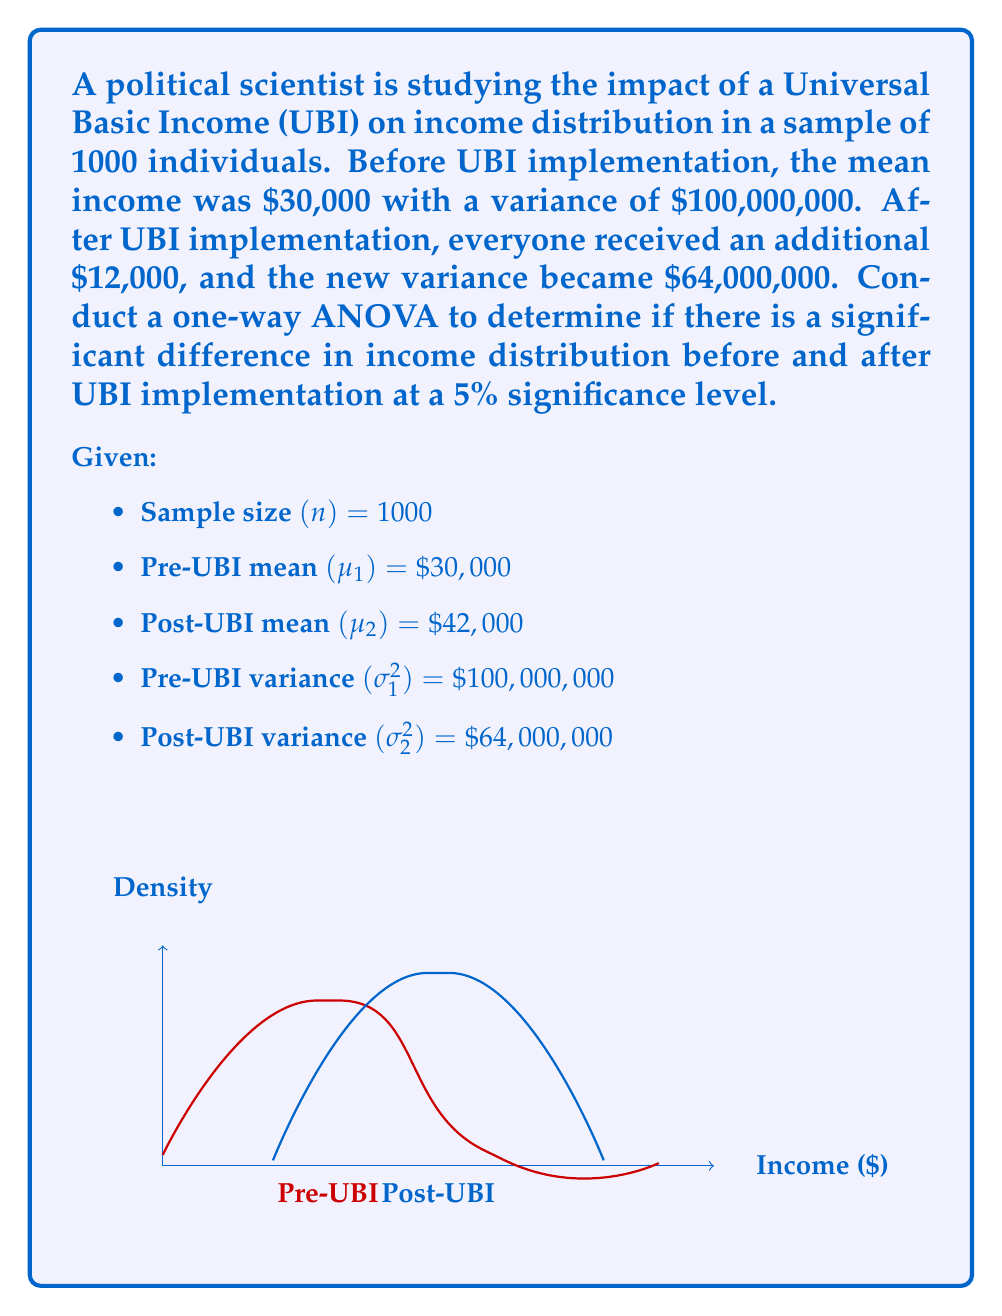Can you solve this math problem? To conduct a one-way ANOVA, we need to follow these steps:

1. Calculate the Sum of Squares Between groups (SSB):
   $$SSB = n(\mu_1 - \overline{X})^2 + n(\mu_2 - \overline{X})^2$$
   where $\overline{X} = \frac{\mu_1 + \mu_2}{2} = \frac{30000 + 42000}{2} = 36000$
   
   $$SSB = 1000(30000 - 36000)^2 + 1000(42000 - 36000)^2$$
   $$SSB = 1000(-6000)^2 + 1000(6000)^2$$
   $$SSB = 36,000,000,000 + 36,000,000,000 = 72,000,000,000$$

2. Calculate the Sum of Squares Within groups (SSW):
   $$SSW = (n-1)\sigma_1^2 + (n-1)\sigma_2^2$$
   $$SSW = 999 \times 100,000,000 + 999 \times 64,000,000$$
   $$SSW = 99,900,000,000 + 63,936,000,000 = 163,836,000,000$$

3. Calculate the Mean Square Between groups (MSB):
   $$MSB = \frac{SSB}{df_B} = \frac{72,000,000,000}{1} = 72,000,000,000$$
   where $df_B = k - 1 = 2 - 1 = 1$ (k is the number of groups)

4. Calculate the Mean Square Within groups (MSW):
   $$MSW = \frac{SSW}{df_W} = \frac{163,836,000,000}{1998} = 81,999,999.00$$
   where $df_W = N - k = 2000 - 2 = 1998$ (N is the total sample size)

5. Calculate the F-statistic:
   $$F = \frac{MSB}{MSW} = \frac{72,000,000,000}{81,999,999.00} = 878.05$$

6. Determine the critical F-value:
   At 5% significance level, with $df_B = 1$ and $df_W = 1998$, the critical F-value is approximately 3.84.

7. Compare the F-statistic to the critical F-value:
   Since 878.05 > 3.84, we reject the null hypothesis.

Therefore, there is a significant difference in income distribution before and after UBI implementation at the 5% significance level.
Answer: Reject null hypothesis; significant difference in income distribution (F = 878.05 > F_crit = 3.84) 